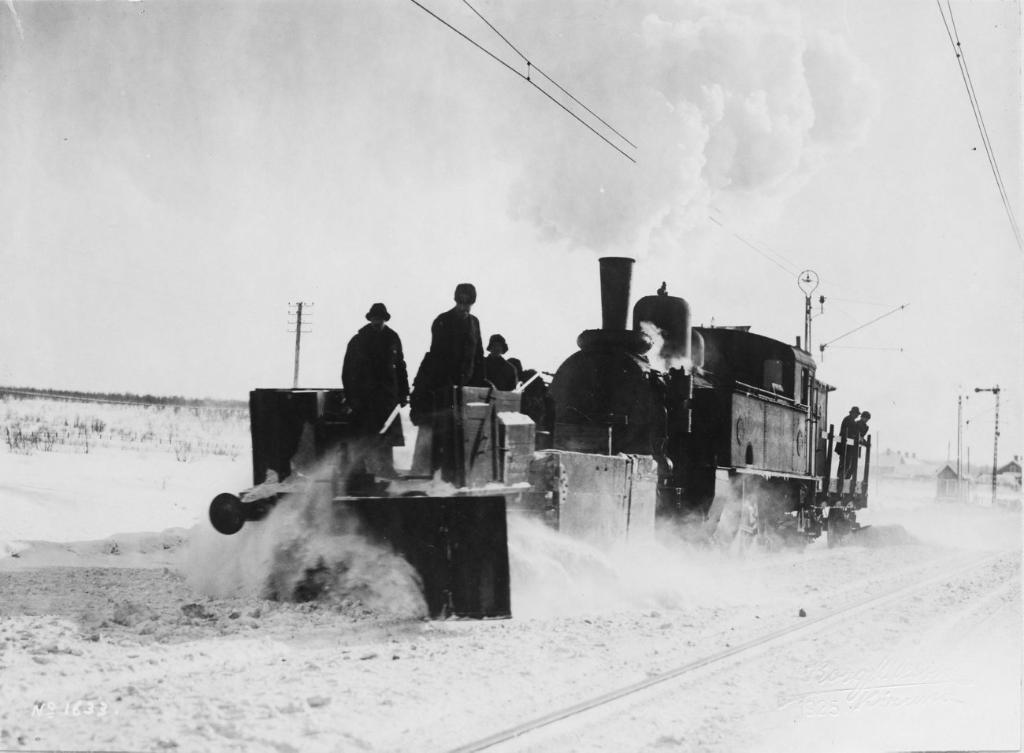What are the people in the image doing? There are people standing on a train in the image. What can be seen in the image besides the people? There are poles and wires visible in the image. What is visible in the background of the image? The sky is visible in the background of the image. How is the image presented in terms of color? The image is black and white in color. How comfortable are the seats on the train in the image? The image does not show any seats, so it is not possible to determine their comfort. 